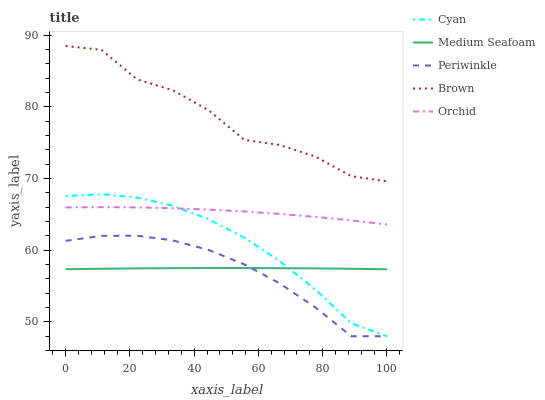Does Periwinkle have the minimum area under the curve?
Answer yes or no. Yes. Does Brown have the maximum area under the curve?
Answer yes or no. Yes. Does Orchid have the minimum area under the curve?
Answer yes or no. No. Does Orchid have the maximum area under the curve?
Answer yes or no. No. Is Medium Seafoam the smoothest?
Answer yes or no. Yes. Is Brown the roughest?
Answer yes or no. Yes. Is Orchid the smoothest?
Answer yes or no. No. Is Orchid the roughest?
Answer yes or no. No. Does Orchid have the lowest value?
Answer yes or no. No. Does Brown have the highest value?
Answer yes or no. Yes. Does Orchid have the highest value?
Answer yes or no. No. Is Orchid less than Brown?
Answer yes or no. Yes. Is Brown greater than Medium Seafoam?
Answer yes or no. Yes. Does Medium Seafoam intersect Cyan?
Answer yes or no. Yes. Is Medium Seafoam less than Cyan?
Answer yes or no. No. Is Medium Seafoam greater than Cyan?
Answer yes or no. No. Does Orchid intersect Brown?
Answer yes or no. No. 